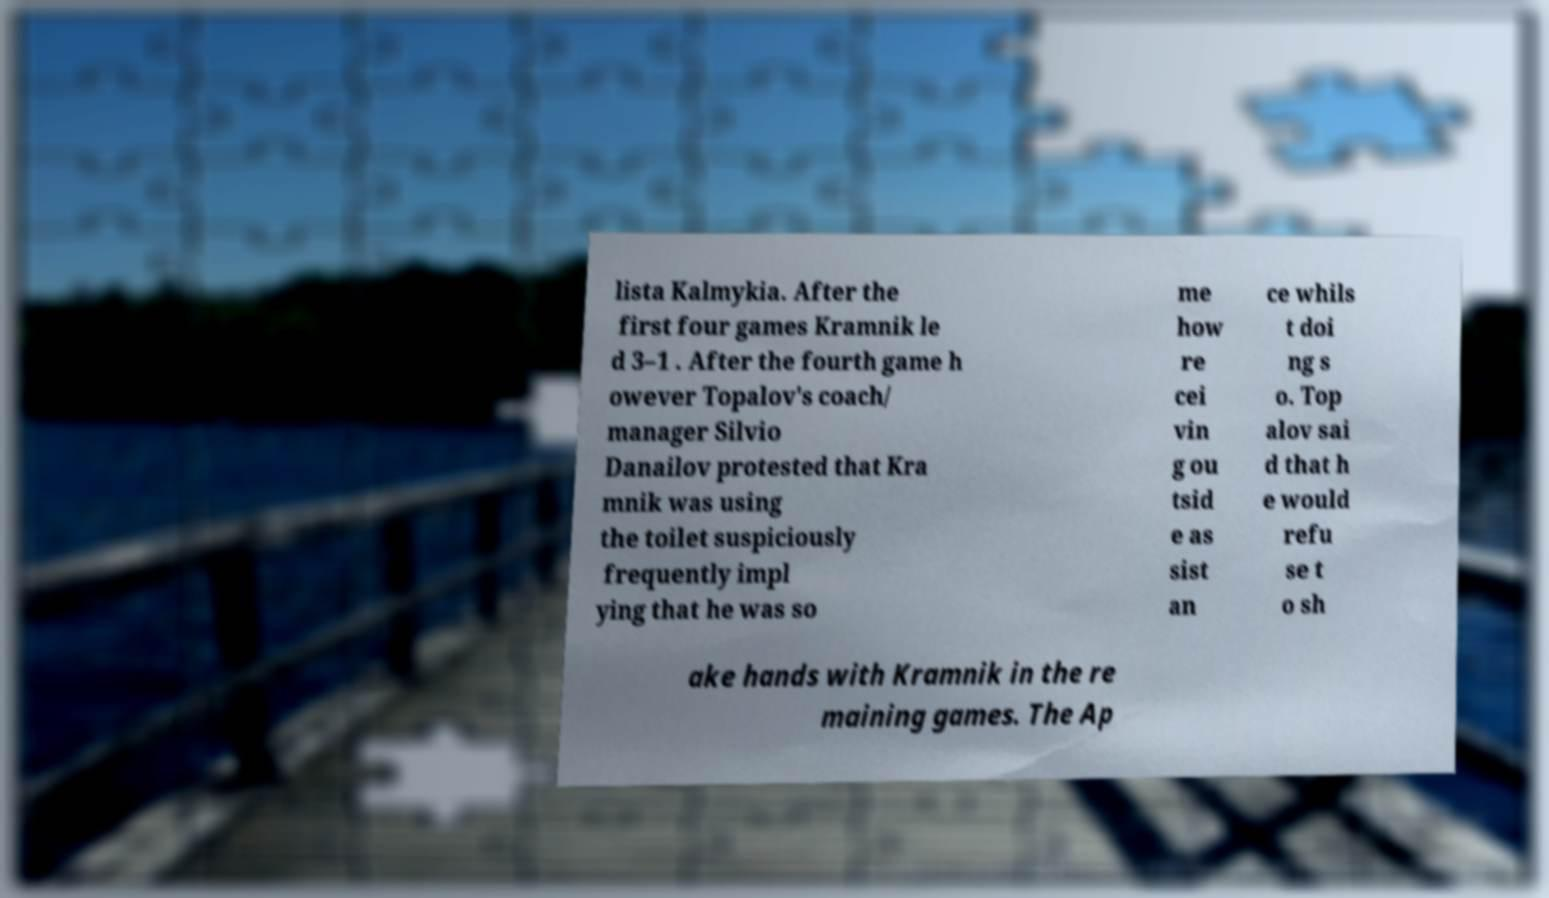Please read and relay the text visible in this image. What does it say? lista Kalmykia. After the first four games Kramnik le d 3–1 . After the fourth game h owever Topalov's coach/ manager Silvio Danailov protested that Kra mnik was using the toilet suspiciously frequently impl ying that he was so me how re cei vin g ou tsid e as sist an ce whils t doi ng s o. Top alov sai d that h e would refu se t o sh ake hands with Kramnik in the re maining games. The Ap 